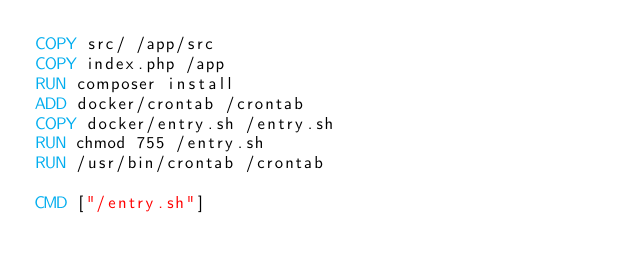<code> <loc_0><loc_0><loc_500><loc_500><_Dockerfile_>COPY src/ /app/src
COPY index.php /app
RUN composer install
ADD docker/crontab /crontab
COPY docker/entry.sh /entry.sh
RUN chmod 755 /entry.sh
RUN /usr/bin/crontab /crontab

CMD ["/entry.sh"]
</code> 